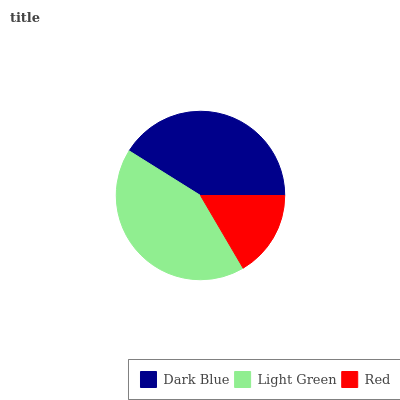Is Red the minimum?
Answer yes or no. Yes. Is Light Green the maximum?
Answer yes or no. Yes. Is Light Green the minimum?
Answer yes or no. No. Is Red the maximum?
Answer yes or no. No. Is Light Green greater than Red?
Answer yes or no. Yes. Is Red less than Light Green?
Answer yes or no. Yes. Is Red greater than Light Green?
Answer yes or no. No. Is Light Green less than Red?
Answer yes or no. No. Is Dark Blue the high median?
Answer yes or no. Yes. Is Dark Blue the low median?
Answer yes or no. Yes. Is Light Green the high median?
Answer yes or no. No. Is Red the low median?
Answer yes or no. No. 